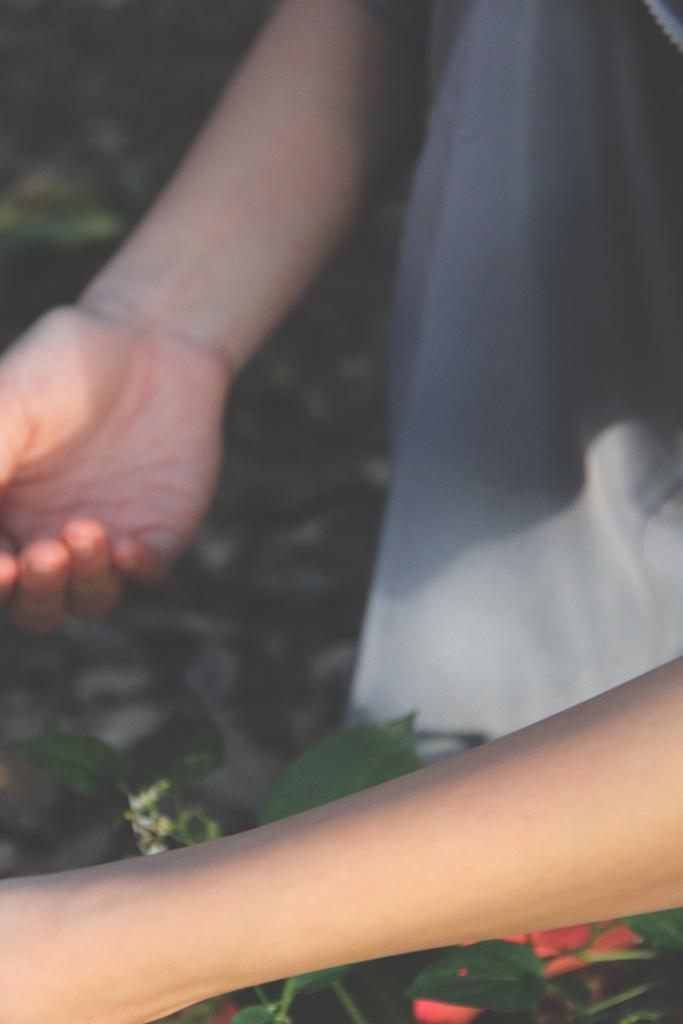Could you give a brief overview of what you see in this image? A human is holding the plant, this person wore t-shirt. 